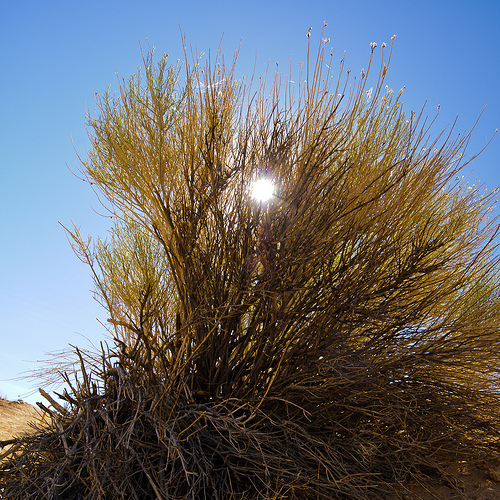<image>
Is there a sun in the tree? Yes. The sun is contained within or inside the tree, showing a containment relationship. 